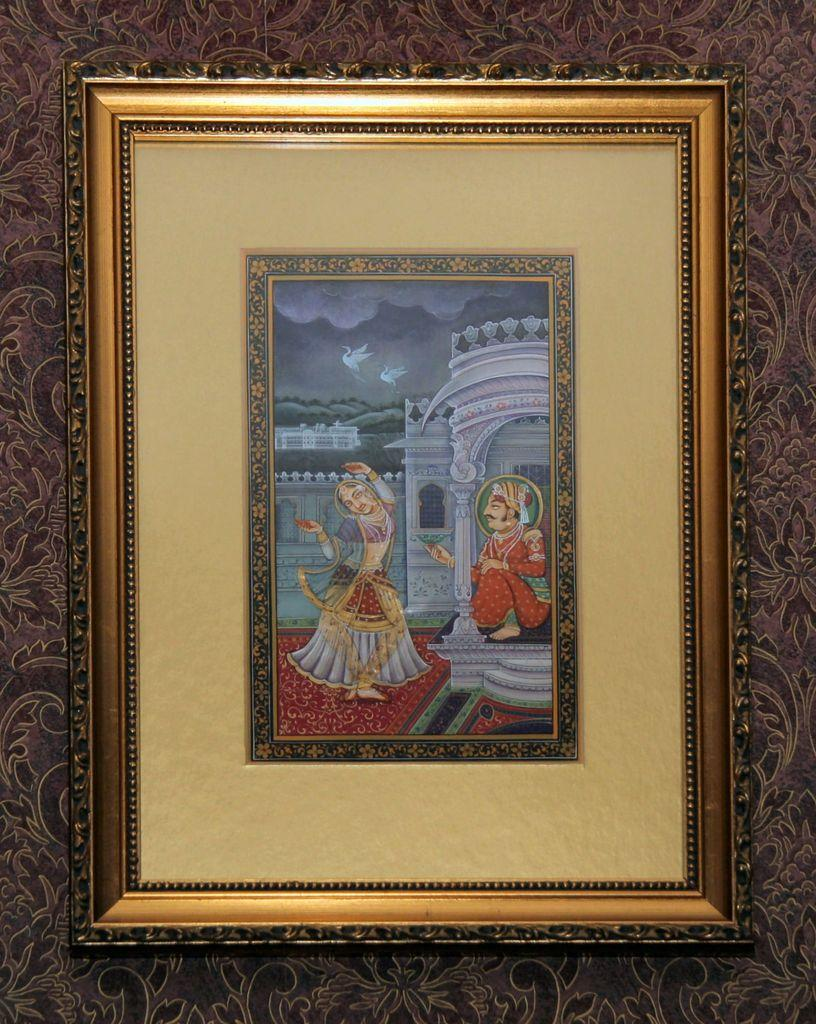What is hanging on the wall in the image? There is a photo frame on the wall. What is inside the photo frame? The photo frame contains a man and a woman. What type of scent can be smelled coming from the photo frame? There is no scent associated with the photo frame in the image. What type of music can be heard playing from the photo frame? There is no music playing from the photo frame in the image. 